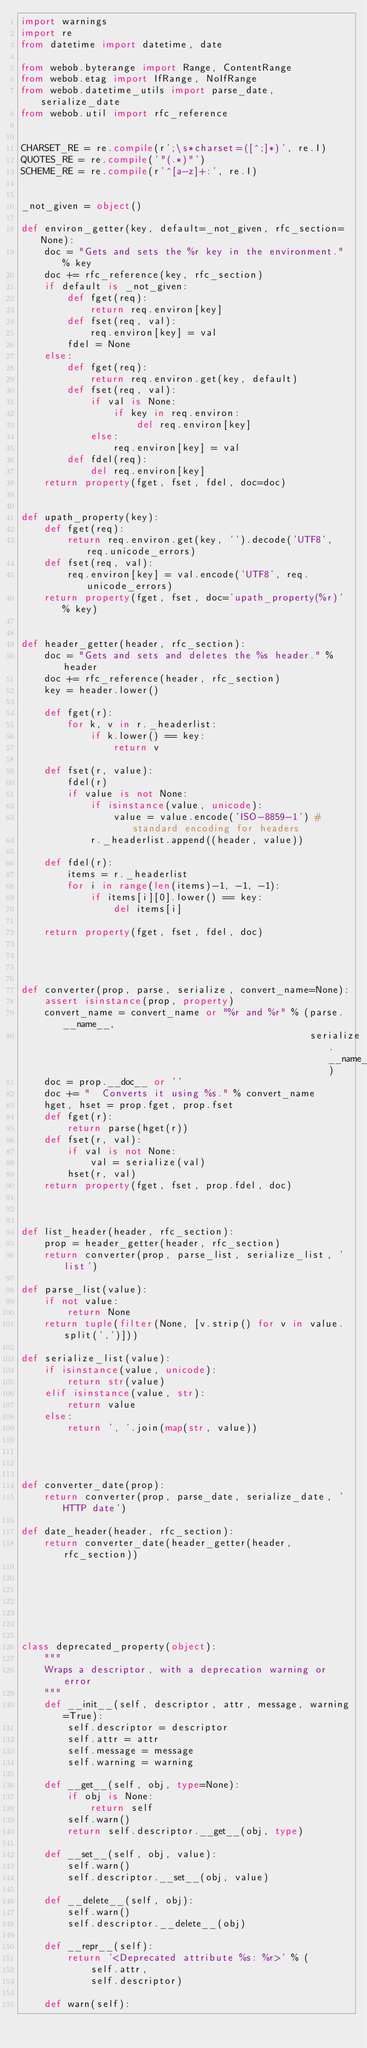Convert code to text. <code><loc_0><loc_0><loc_500><loc_500><_Python_>import warnings
import re
from datetime import datetime, date

from webob.byterange import Range, ContentRange
from webob.etag import IfRange, NoIfRange
from webob.datetime_utils import parse_date, serialize_date
from webob.util import rfc_reference


CHARSET_RE = re.compile(r';\s*charset=([^;]*)', re.I)
QUOTES_RE = re.compile('"(.*)"')
SCHEME_RE = re.compile(r'^[a-z]+:', re.I)


_not_given = object()

def environ_getter(key, default=_not_given, rfc_section=None):
    doc = "Gets and sets the %r key in the environment." % key
    doc += rfc_reference(key, rfc_section)
    if default is _not_given:
        def fget(req):
            return req.environ[key]
        def fset(req, val):
            req.environ[key] = val
        fdel = None
    else:
        def fget(req):
            return req.environ.get(key, default)
        def fset(req, val):
            if val is None:
                if key in req.environ:
                    del req.environ[key]
            else:
                req.environ[key] = val
        def fdel(req):
            del req.environ[key]
    return property(fget, fset, fdel, doc=doc)


def upath_property(key):
    def fget(req):
        return req.environ.get(key, '').decode('UTF8', req.unicode_errors)
    def fset(req, val):
        req.environ[key] = val.encode('UTF8', req.unicode_errors)
    return property(fget, fset, doc='upath_property(%r)' % key)


def header_getter(header, rfc_section):
    doc = "Gets and sets and deletes the %s header." % header
    doc += rfc_reference(header, rfc_section)
    key = header.lower()

    def fget(r):
        for k, v in r._headerlist:
            if k.lower() == key:
                return v

    def fset(r, value):
        fdel(r)
        if value is not None:
            if isinstance(value, unicode):
                value = value.encode('ISO-8859-1') # standard encoding for headers
            r._headerlist.append((header, value))

    def fdel(r):
        items = r._headerlist
        for i in range(len(items)-1, -1, -1):
            if items[i][0].lower() == key:
                del items[i]

    return property(fget, fset, fdel, doc)




def converter(prop, parse, serialize, convert_name=None):
    assert isinstance(prop, property)
    convert_name = convert_name or "%r and %r" % (parse.__name__,
                                                  serialize.__name__)
    doc = prop.__doc__ or ''
    doc += "  Converts it using %s." % convert_name
    hget, hset = prop.fget, prop.fset
    def fget(r):
        return parse(hget(r))
    def fset(r, val):
        if val is not None:
            val = serialize(val)
        hset(r, val)
    return property(fget, fset, prop.fdel, doc)



def list_header(header, rfc_section):
    prop = header_getter(header, rfc_section)
    return converter(prop, parse_list, serialize_list, 'list')

def parse_list(value):
    if not value:
        return None
    return tuple(filter(None, [v.strip() for v in value.split(',')]))

def serialize_list(value):
    if isinstance(value, unicode):
        return str(value)
    elif isinstance(value, str):
        return value
    else:
        return ', '.join(map(str, value))




def converter_date(prop):
    return converter(prop, parse_date, serialize_date, 'HTTP date')

def date_header(header, rfc_section):
    return converter_date(header_getter(header, rfc_section))







class deprecated_property(object):
    """
    Wraps a descriptor, with a deprecation warning or error
    """
    def __init__(self, descriptor, attr, message, warning=True):
        self.descriptor = descriptor
        self.attr = attr
        self.message = message
        self.warning = warning

    def __get__(self, obj, type=None):
        if obj is None:
            return self
        self.warn()
        return self.descriptor.__get__(obj, type)

    def __set__(self, obj, value):
        self.warn()
        self.descriptor.__set__(obj, value)

    def __delete__(self, obj):
        self.warn()
        self.descriptor.__delete__(obj)

    def __repr__(self):
        return '<Deprecated attribute %s: %r>' % (
            self.attr,
            self.descriptor)

    def warn(self):</code> 